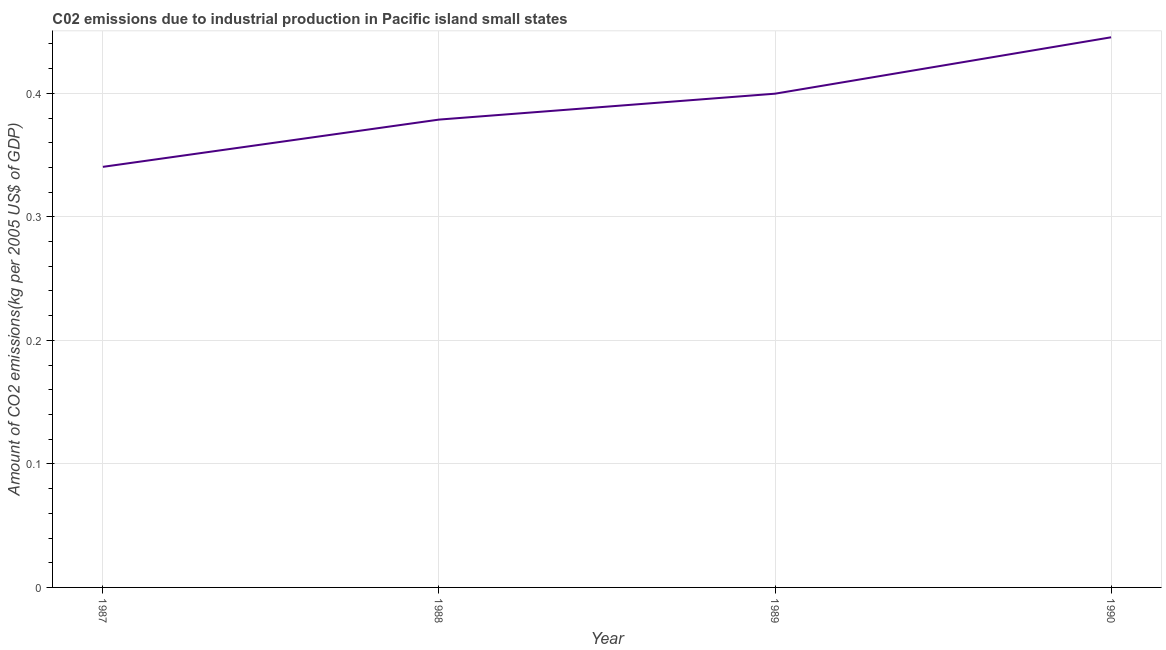What is the amount of co2 emissions in 1990?
Your answer should be very brief. 0.45. Across all years, what is the maximum amount of co2 emissions?
Provide a succinct answer. 0.45. Across all years, what is the minimum amount of co2 emissions?
Keep it short and to the point. 0.34. In which year was the amount of co2 emissions minimum?
Offer a terse response. 1987. What is the sum of the amount of co2 emissions?
Keep it short and to the point. 1.56. What is the difference between the amount of co2 emissions in 1988 and 1990?
Your response must be concise. -0.07. What is the average amount of co2 emissions per year?
Provide a short and direct response. 0.39. What is the median amount of co2 emissions?
Keep it short and to the point. 0.39. In how many years, is the amount of co2 emissions greater than 0.02 kg per 2005 US$ of GDP?
Make the answer very short. 4. What is the ratio of the amount of co2 emissions in 1989 to that in 1990?
Provide a succinct answer. 0.9. Is the amount of co2 emissions in 1987 less than that in 1988?
Offer a terse response. Yes. What is the difference between the highest and the second highest amount of co2 emissions?
Provide a short and direct response. 0.05. Is the sum of the amount of co2 emissions in 1989 and 1990 greater than the maximum amount of co2 emissions across all years?
Provide a succinct answer. Yes. What is the difference between the highest and the lowest amount of co2 emissions?
Offer a very short reply. 0.1. Does the amount of co2 emissions monotonically increase over the years?
Your response must be concise. Yes. How many years are there in the graph?
Make the answer very short. 4. What is the difference between two consecutive major ticks on the Y-axis?
Your response must be concise. 0.1. What is the title of the graph?
Ensure brevity in your answer.  C02 emissions due to industrial production in Pacific island small states. What is the label or title of the X-axis?
Your answer should be very brief. Year. What is the label or title of the Y-axis?
Keep it short and to the point. Amount of CO2 emissions(kg per 2005 US$ of GDP). What is the Amount of CO2 emissions(kg per 2005 US$ of GDP) of 1987?
Make the answer very short. 0.34. What is the Amount of CO2 emissions(kg per 2005 US$ of GDP) of 1988?
Your response must be concise. 0.38. What is the Amount of CO2 emissions(kg per 2005 US$ of GDP) in 1989?
Provide a short and direct response. 0.4. What is the Amount of CO2 emissions(kg per 2005 US$ of GDP) in 1990?
Your answer should be compact. 0.45. What is the difference between the Amount of CO2 emissions(kg per 2005 US$ of GDP) in 1987 and 1988?
Offer a terse response. -0.04. What is the difference between the Amount of CO2 emissions(kg per 2005 US$ of GDP) in 1987 and 1989?
Make the answer very short. -0.06. What is the difference between the Amount of CO2 emissions(kg per 2005 US$ of GDP) in 1987 and 1990?
Offer a very short reply. -0.1. What is the difference between the Amount of CO2 emissions(kg per 2005 US$ of GDP) in 1988 and 1989?
Your answer should be compact. -0.02. What is the difference between the Amount of CO2 emissions(kg per 2005 US$ of GDP) in 1988 and 1990?
Offer a terse response. -0.07. What is the difference between the Amount of CO2 emissions(kg per 2005 US$ of GDP) in 1989 and 1990?
Offer a terse response. -0.05. What is the ratio of the Amount of CO2 emissions(kg per 2005 US$ of GDP) in 1987 to that in 1988?
Keep it short and to the point. 0.9. What is the ratio of the Amount of CO2 emissions(kg per 2005 US$ of GDP) in 1987 to that in 1989?
Give a very brief answer. 0.85. What is the ratio of the Amount of CO2 emissions(kg per 2005 US$ of GDP) in 1987 to that in 1990?
Your answer should be compact. 0.77. What is the ratio of the Amount of CO2 emissions(kg per 2005 US$ of GDP) in 1988 to that in 1989?
Your answer should be very brief. 0.95. What is the ratio of the Amount of CO2 emissions(kg per 2005 US$ of GDP) in 1989 to that in 1990?
Offer a very short reply. 0.9. 